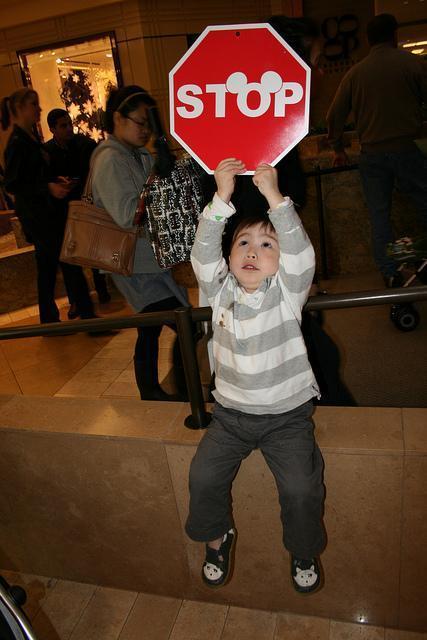How many people are in the picture?
Give a very brief answer. 5. How many kites are there?
Give a very brief answer. 0. 